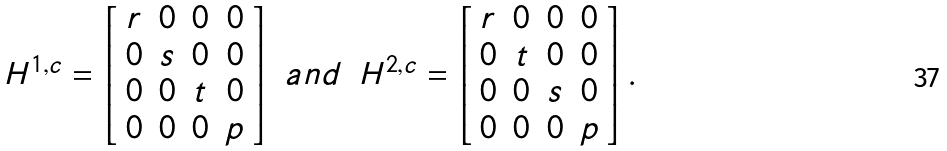<formula> <loc_0><loc_0><loc_500><loc_500>\begin{array} { c c c } H ^ { 1 , c } = \left [ \begin{array} { c c c c } r & 0 & 0 & 0 \\ 0 & s & 0 & 0 \\ 0 & 0 & t & 0 \\ 0 & 0 & 0 & p \end{array} \right ] & a n d & H ^ { 2 , c } = \left [ \begin{array} { c c c c } r & 0 & 0 & 0 \\ 0 & t & 0 & 0 \\ 0 & 0 & s & 0 \\ 0 & 0 & 0 & p \end{array} \right ] . \end{array}</formula> 